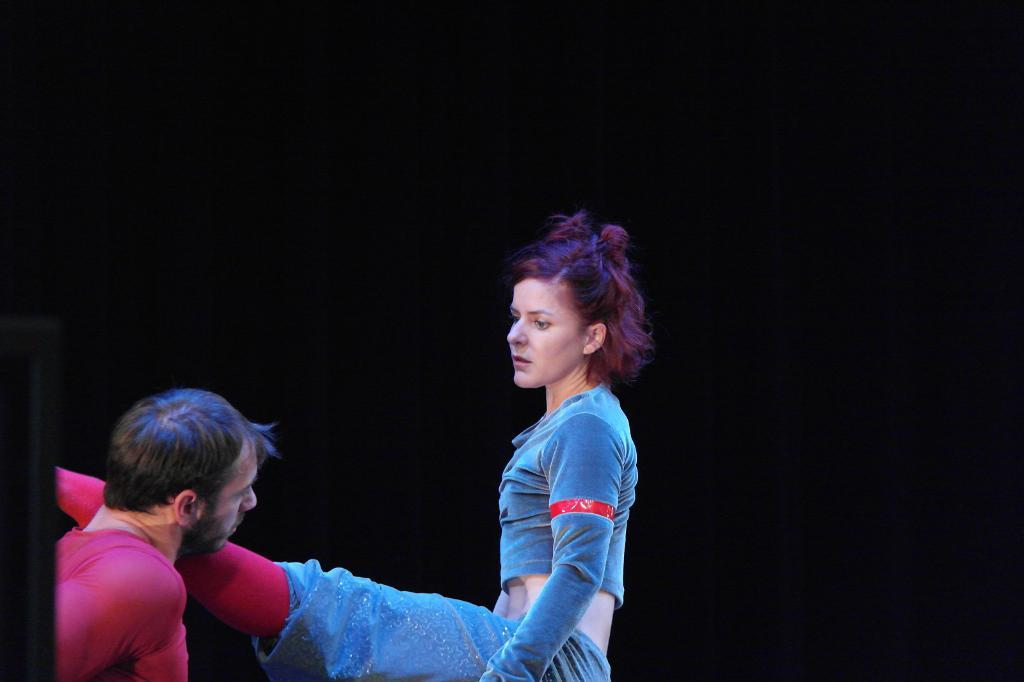What is the woman in the image wearing? The woman is wearing a blue dress in the image. How is the woman described in the image? The woman is described as stunning. What is the person on the left side of the image wearing? The person on the left side of the image is wearing a maroon t-shirt. What color is the background of the image? The background of the image is black. What type of feast is being prepared in the image? There is no feast being prepared in the image; it only features a woman and a person wearing specific clothing against a black background. 